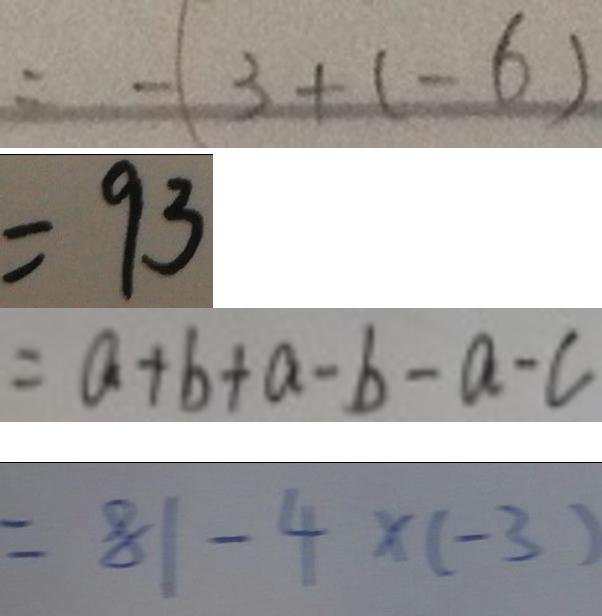Convert formula to latex. <formula><loc_0><loc_0><loc_500><loc_500>= - 3 + ( - 6 ) 
 = 9 3 
 = a + b + a - b - a - c 
 = 8 1 - 4 \times ( - 3 )</formula> 